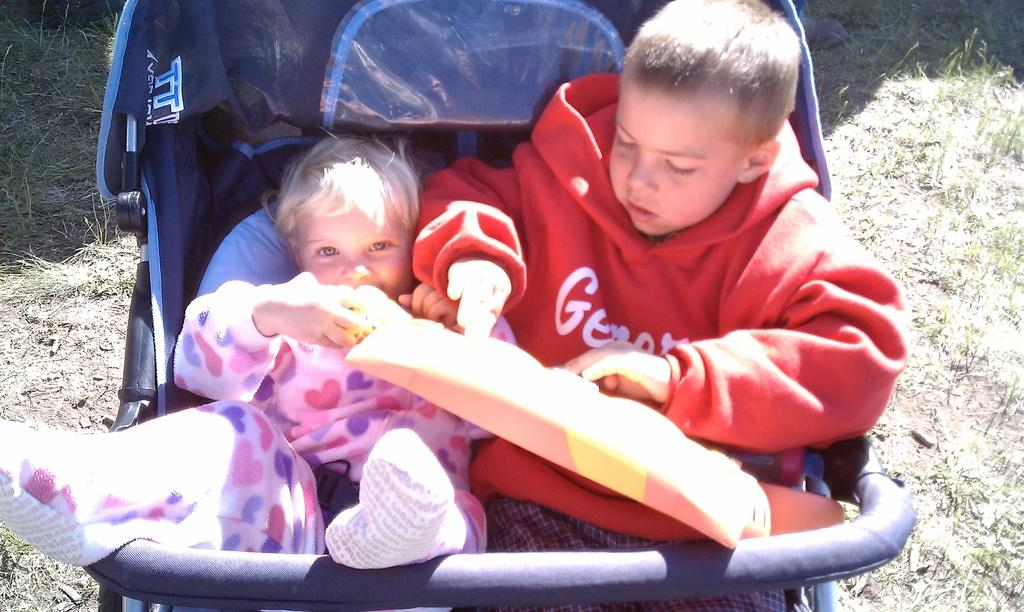How many kids are in the image? There are two kids in the image. What are the kids in the image doing? The kids are in a stroller in the image. What type of surface is visible at the bottom of the image? There is grass and soil at the bottom of the image. What type of crack can be seen in the image? There is no crack present in the image. What surprise is waiting for the kids in the stroller? There is no indication of a surprise in the image; it simply shows two kids in a stroller on a grassy and soil-covered surface. 